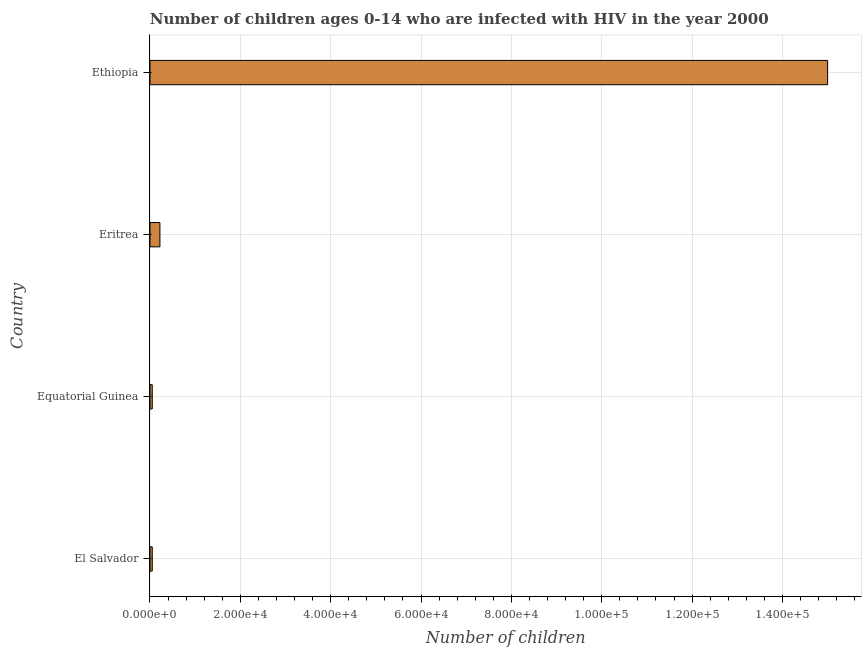Does the graph contain any zero values?
Your answer should be compact. No. Does the graph contain grids?
Ensure brevity in your answer.  Yes. What is the title of the graph?
Your answer should be compact. Number of children ages 0-14 who are infected with HIV in the year 2000. What is the label or title of the X-axis?
Give a very brief answer. Number of children. What is the label or title of the Y-axis?
Offer a very short reply. Country. What is the number of children living with hiv in Eritrea?
Your answer should be very brief. 2200. Across all countries, what is the maximum number of children living with hiv?
Provide a succinct answer. 1.50e+05. In which country was the number of children living with hiv maximum?
Ensure brevity in your answer.  Ethiopia. In which country was the number of children living with hiv minimum?
Offer a terse response. El Salvador. What is the sum of the number of children living with hiv?
Your answer should be compact. 1.53e+05. What is the difference between the number of children living with hiv in Equatorial Guinea and Ethiopia?
Give a very brief answer. -1.50e+05. What is the average number of children living with hiv per country?
Give a very brief answer. 3.83e+04. What is the median number of children living with hiv?
Keep it short and to the point. 1350. In how many countries, is the number of children living with hiv greater than 152000 ?
Offer a very short reply. 0. Is the difference between the number of children living with hiv in Equatorial Guinea and Eritrea greater than the difference between any two countries?
Your response must be concise. No. What is the difference between the highest and the second highest number of children living with hiv?
Your answer should be compact. 1.48e+05. Is the sum of the number of children living with hiv in El Salvador and Equatorial Guinea greater than the maximum number of children living with hiv across all countries?
Keep it short and to the point. No. What is the difference between the highest and the lowest number of children living with hiv?
Your answer should be compact. 1.50e+05. In how many countries, is the number of children living with hiv greater than the average number of children living with hiv taken over all countries?
Keep it short and to the point. 1. What is the difference between two consecutive major ticks on the X-axis?
Provide a short and direct response. 2.00e+04. Are the values on the major ticks of X-axis written in scientific E-notation?
Offer a terse response. Yes. What is the Number of children in Equatorial Guinea?
Ensure brevity in your answer.  500. What is the Number of children in Eritrea?
Ensure brevity in your answer.  2200. What is the Number of children in Ethiopia?
Make the answer very short. 1.50e+05. What is the difference between the Number of children in El Salvador and Equatorial Guinea?
Provide a succinct answer. 0. What is the difference between the Number of children in El Salvador and Eritrea?
Ensure brevity in your answer.  -1700. What is the difference between the Number of children in El Salvador and Ethiopia?
Offer a very short reply. -1.50e+05. What is the difference between the Number of children in Equatorial Guinea and Eritrea?
Your answer should be very brief. -1700. What is the difference between the Number of children in Equatorial Guinea and Ethiopia?
Keep it short and to the point. -1.50e+05. What is the difference between the Number of children in Eritrea and Ethiopia?
Your response must be concise. -1.48e+05. What is the ratio of the Number of children in El Salvador to that in Equatorial Guinea?
Your answer should be compact. 1. What is the ratio of the Number of children in El Salvador to that in Eritrea?
Provide a succinct answer. 0.23. What is the ratio of the Number of children in El Salvador to that in Ethiopia?
Provide a succinct answer. 0. What is the ratio of the Number of children in Equatorial Guinea to that in Eritrea?
Provide a short and direct response. 0.23. What is the ratio of the Number of children in Equatorial Guinea to that in Ethiopia?
Keep it short and to the point. 0. What is the ratio of the Number of children in Eritrea to that in Ethiopia?
Make the answer very short. 0.01. 